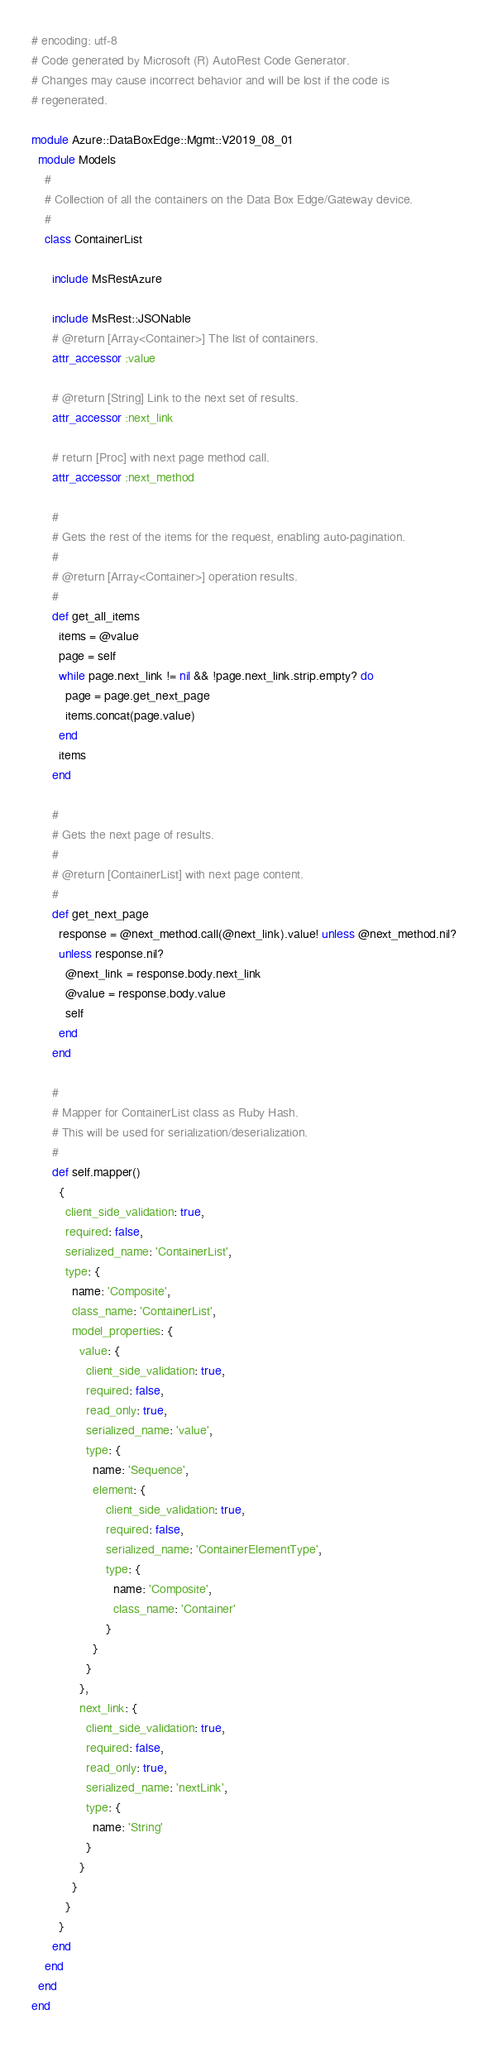<code> <loc_0><loc_0><loc_500><loc_500><_Ruby_># encoding: utf-8
# Code generated by Microsoft (R) AutoRest Code Generator.
# Changes may cause incorrect behavior and will be lost if the code is
# regenerated.

module Azure::DataBoxEdge::Mgmt::V2019_08_01
  module Models
    #
    # Collection of all the containers on the Data Box Edge/Gateway device.
    #
    class ContainerList

      include MsRestAzure

      include MsRest::JSONable
      # @return [Array<Container>] The list of containers.
      attr_accessor :value

      # @return [String] Link to the next set of results.
      attr_accessor :next_link

      # return [Proc] with next page method call.
      attr_accessor :next_method

      #
      # Gets the rest of the items for the request, enabling auto-pagination.
      #
      # @return [Array<Container>] operation results.
      #
      def get_all_items
        items = @value
        page = self
        while page.next_link != nil && !page.next_link.strip.empty? do
          page = page.get_next_page
          items.concat(page.value)
        end
        items
      end

      #
      # Gets the next page of results.
      #
      # @return [ContainerList] with next page content.
      #
      def get_next_page
        response = @next_method.call(@next_link).value! unless @next_method.nil?
        unless response.nil?
          @next_link = response.body.next_link
          @value = response.body.value
          self
        end
      end

      #
      # Mapper for ContainerList class as Ruby Hash.
      # This will be used for serialization/deserialization.
      #
      def self.mapper()
        {
          client_side_validation: true,
          required: false,
          serialized_name: 'ContainerList',
          type: {
            name: 'Composite',
            class_name: 'ContainerList',
            model_properties: {
              value: {
                client_side_validation: true,
                required: false,
                read_only: true,
                serialized_name: 'value',
                type: {
                  name: 'Sequence',
                  element: {
                      client_side_validation: true,
                      required: false,
                      serialized_name: 'ContainerElementType',
                      type: {
                        name: 'Composite',
                        class_name: 'Container'
                      }
                  }
                }
              },
              next_link: {
                client_side_validation: true,
                required: false,
                read_only: true,
                serialized_name: 'nextLink',
                type: {
                  name: 'String'
                }
              }
            }
          }
        }
      end
    end
  end
end
</code> 